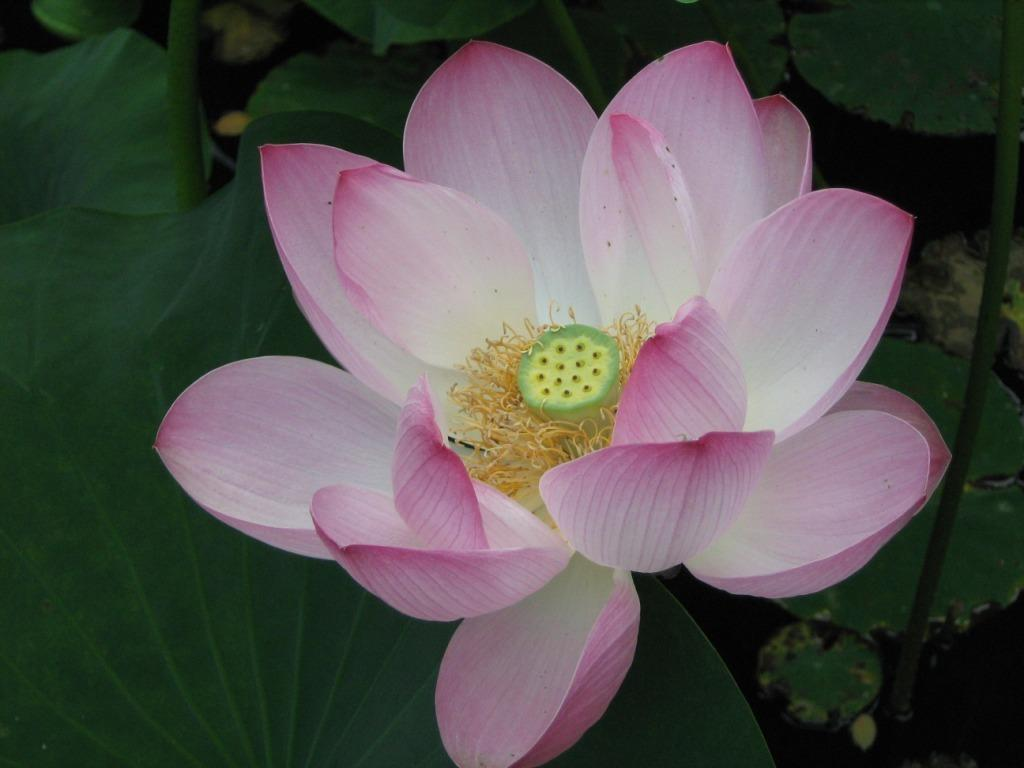What type of plant can be seen in the image? There is a flower in the image. What other parts of the plant are visible? There are leaves and stems in the image. Is there any liquid visible in the image? Yes, there is water visible in the bottom right corner of the image. What type of ear can be seen in the image? There is no ear present in the image; it features a flower, leaves, and stems. Can you tell me how many plants are depicted in the image? The image only shows one plant, which consists of a flower, leaves, and stems. 